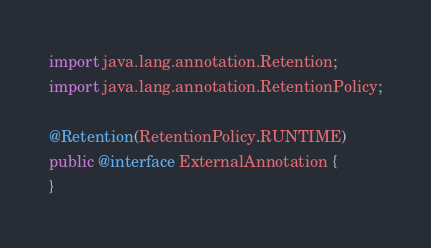<code> <loc_0><loc_0><loc_500><loc_500><_Java_>import java.lang.annotation.Retention;
import java.lang.annotation.RetentionPolicy;

@Retention(RetentionPolicy.RUNTIME)
public @interface ExternalAnnotation {
}
</code> 